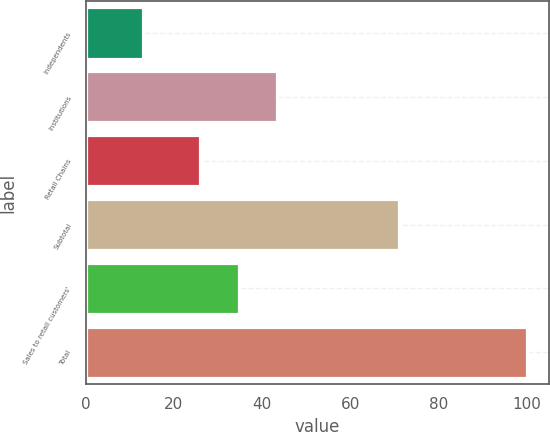Convert chart to OTSL. <chart><loc_0><loc_0><loc_500><loc_500><bar_chart><fcel>Independents<fcel>Institutions<fcel>Retail Chains<fcel>Subtotal<fcel>Sales to retail customers'<fcel>Total<nl><fcel>13<fcel>43.4<fcel>26<fcel>71<fcel>34.7<fcel>100<nl></chart> 